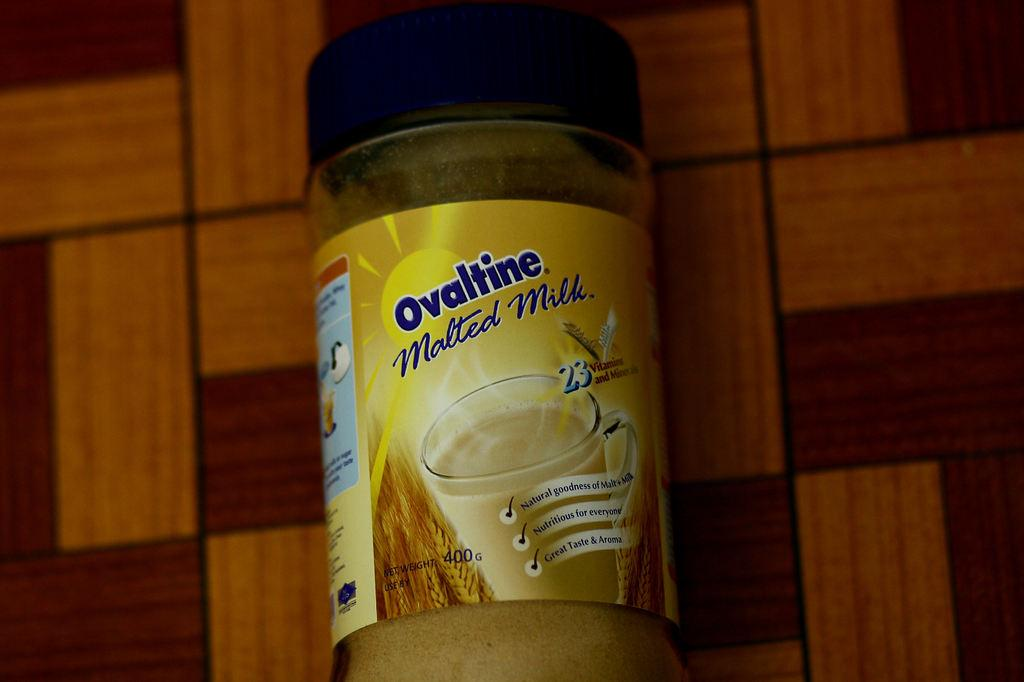<image>
Provide a brief description of the given image. a bottle of ovaltine malted milk in blue 